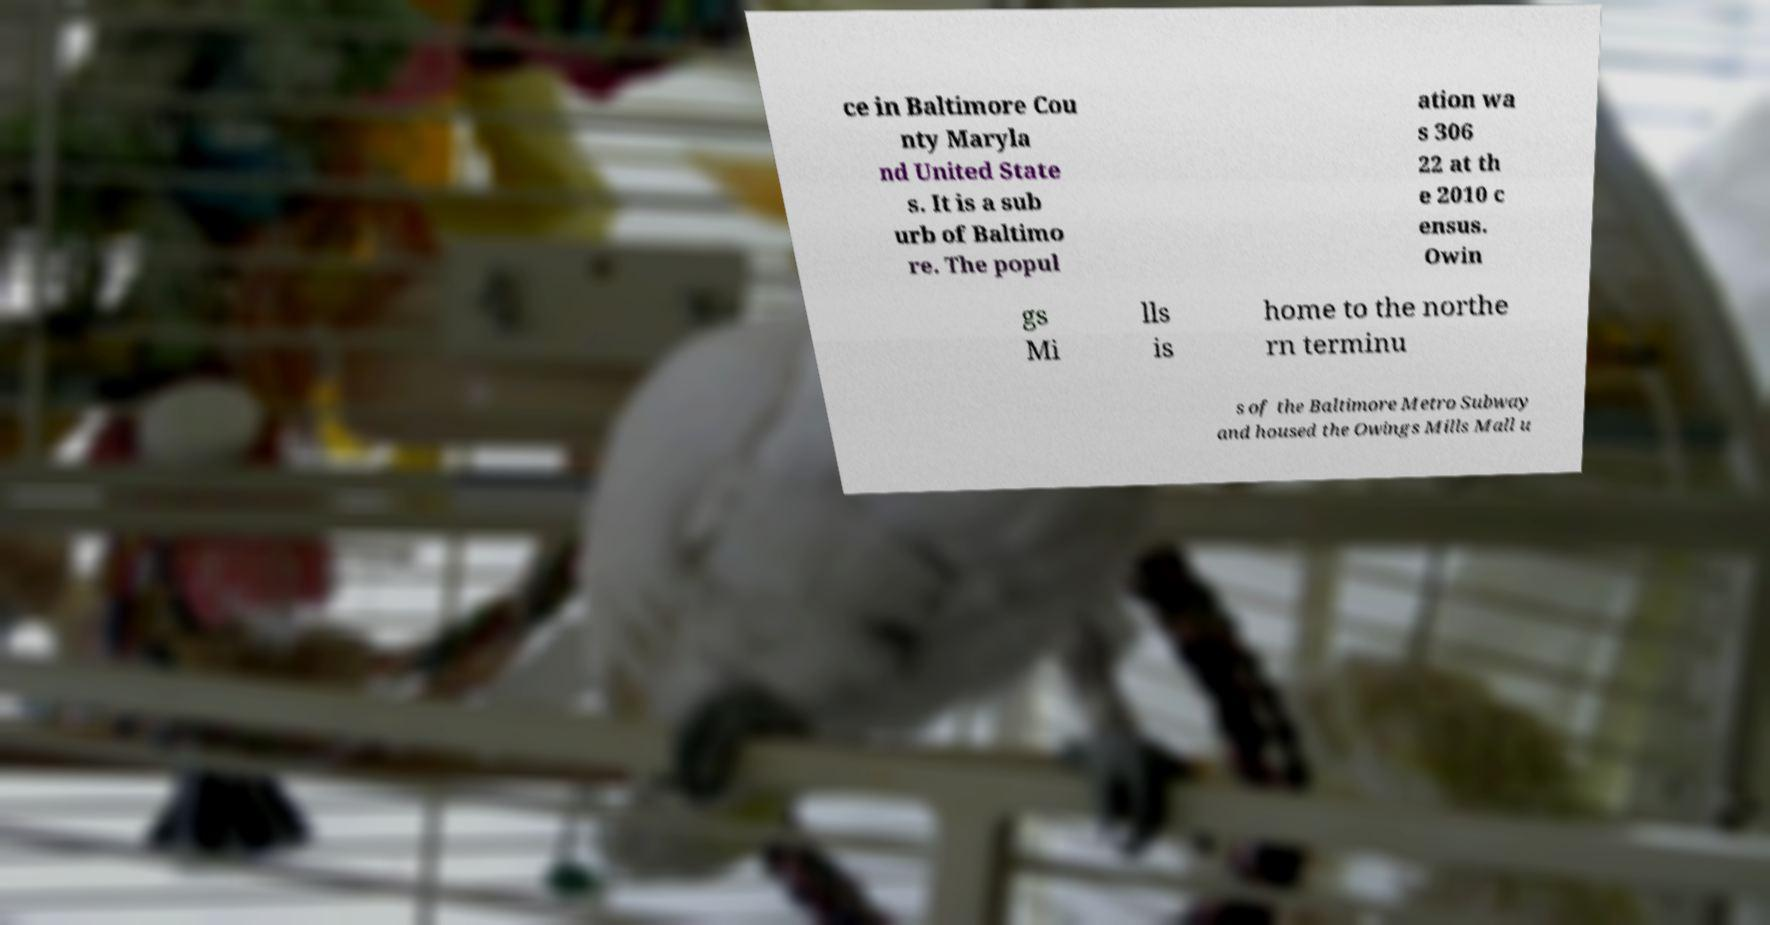Could you extract and type out the text from this image? ce in Baltimore Cou nty Maryla nd United State s. It is a sub urb of Baltimo re. The popul ation wa s 306 22 at th e 2010 c ensus. Owin gs Mi lls is home to the northe rn terminu s of the Baltimore Metro Subway and housed the Owings Mills Mall u 